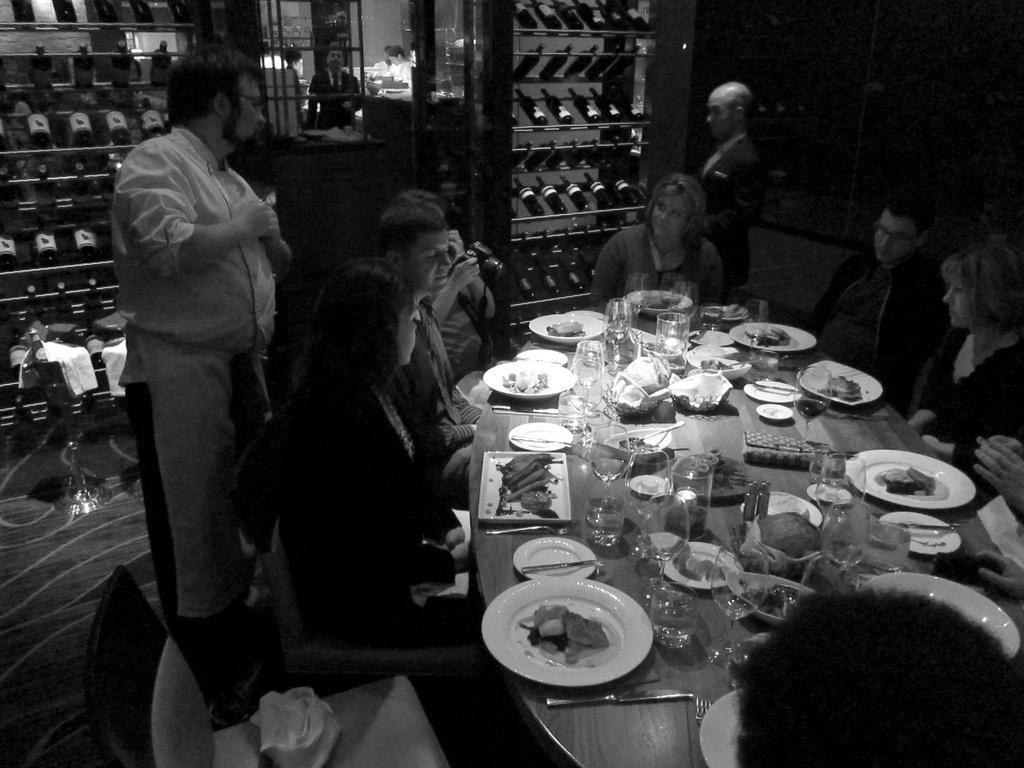How many people are in the image? There are multiple people in the image. What are the positions of the people in the image? Two of the people are standing, and the rest of the people are sitting. What is present on the table in the image? There are plates, glasses, and napkins on the table. What type of instrument is being played by the person standing next to the table? There is no instrument present in the image, and no person is playing an instrument. 